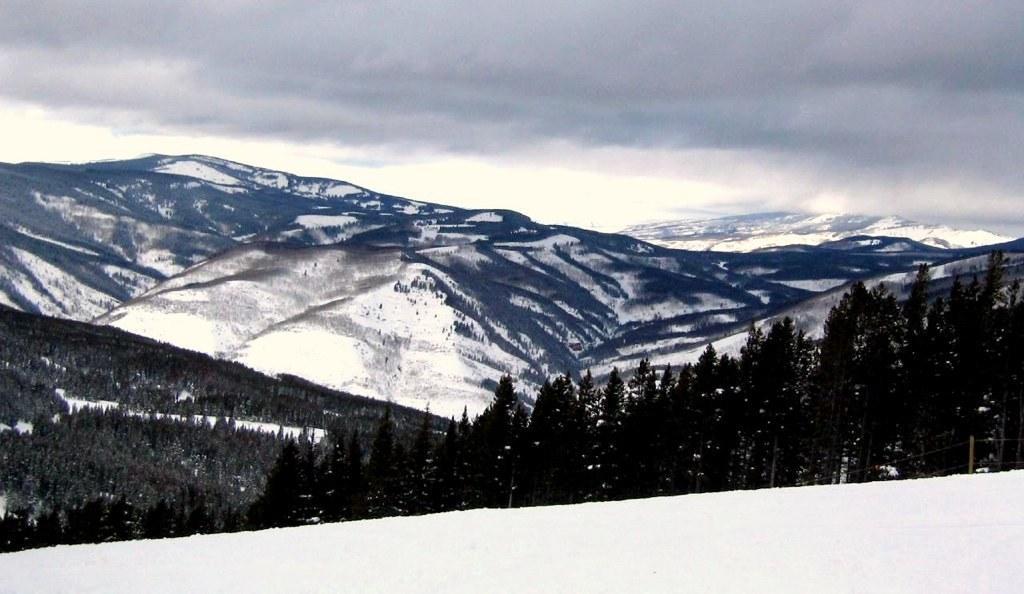Describe this image in one or two sentences. This picture is clicked outside the city. In the foreground we can see there is a lot of snow and we can see the trees. In the background we can see the sky, hills and some other objects. 